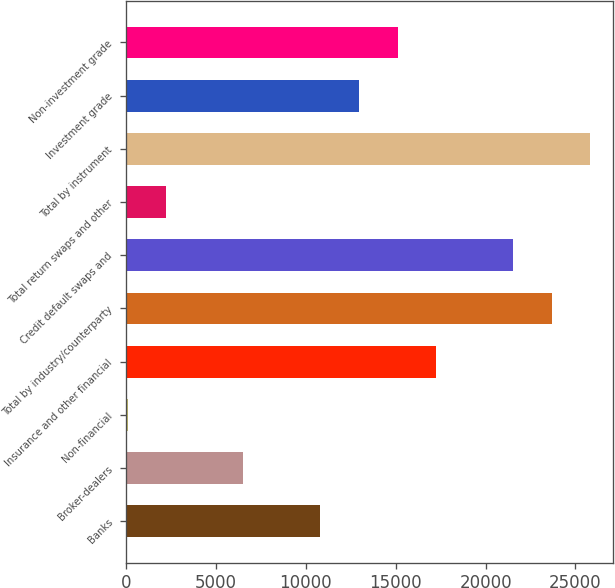<chart> <loc_0><loc_0><loc_500><loc_500><bar_chart><fcel>Banks<fcel>Broker-dealers<fcel>Non-financial<fcel>Insurance and other financial<fcel>Total by industry/counterparty<fcel>Credit default swaps and<fcel>Total return swaps and other<fcel>Total by instrument<fcel>Investment grade<fcel>Non-investment grade<nl><fcel>10812<fcel>6523.6<fcel>91<fcel>17244.6<fcel>23677.2<fcel>21533<fcel>2235.2<fcel>25821.4<fcel>12956.2<fcel>15100.4<nl></chart> 